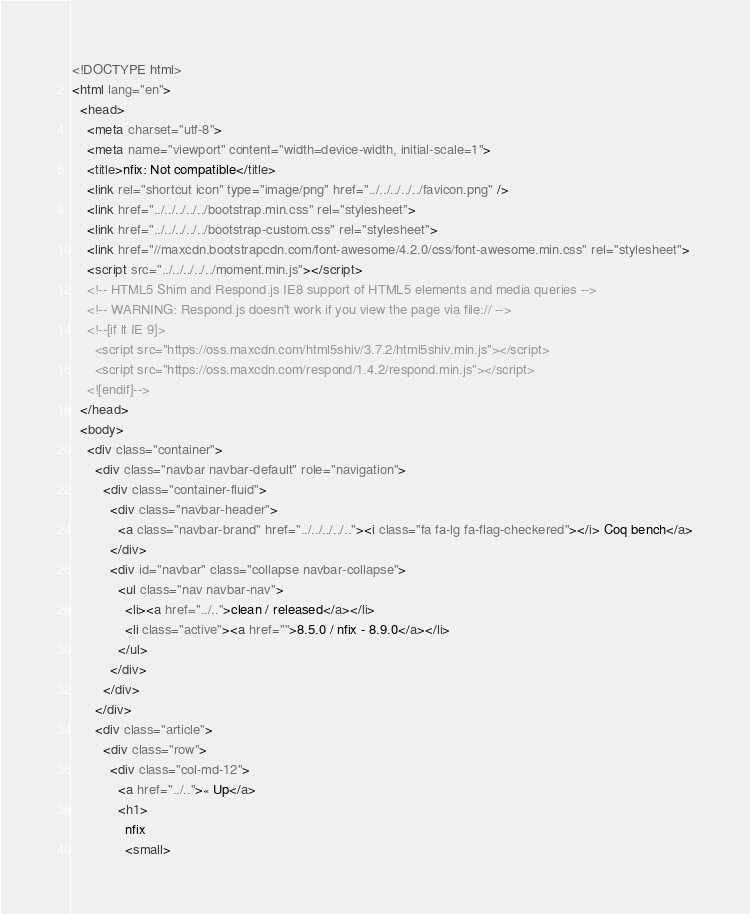Convert code to text. <code><loc_0><loc_0><loc_500><loc_500><_HTML_><!DOCTYPE html>
<html lang="en">
  <head>
    <meta charset="utf-8">
    <meta name="viewport" content="width=device-width, initial-scale=1">
    <title>nfix: Not compatible</title>
    <link rel="shortcut icon" type="image/png" href="../../../../../favicon.png" />
    <link href="../../../../../bootstrap.min.css" rel="stylesheet">
    <link href="../../../../../bootstrap-custom.css" rel="stylesheet">
    <link href="//maxcdn.bootstrapcdn.com/font-awesome/4.2.0/css/font-awesome.min.css" rel="stylesheet">
    <script src="../../../../../moment.min.js"></script>
    <!-- HTML5 Shim and Respond.js IE8 support of HTML5 elements and media queries -->
    <!-- WARNING: Respond.js doesn't work if you view the page via file:// -->
    <!--[if lt IE 9]>
      <script src="https://oss.maxcdn.com/html5shiv/3.7.2/html5shiv.min.js"></script>
      <script src="https://oss.maxcdn.com/respond/1.4.2/respond.min.js"></script>
    <![endif]-->
  </head>
  <body>
    <div class="container">
      <div class="navbar navbar-default" role="navigation">
        <div class="container-fluid">
          <div class="navbar-header">
            <a class="navbar-brand" href="../../../../.."><i class="fa fa-lg fa-flag-checkered"></i> Coq bench</a>
          </div>
          <div id="navbar" class="collapse navbar-collapse">
            <ul class="nav navbar-nav">
              <li><a href="../..">clean / released</a></li>
              <li class="active"><a href="">8.5.0 / nfix - 8.9.0</a></li>
            </ul>
          </div>
        </div>
      </div>
      <div class="article">
        <div class="row">
          <div class="col-md-12">
            <a href="../..">« Up</a>
            <h1>
              nfix
              <small></code> 